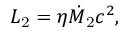Convert formula to latex. <formula><loc_0><loc_0><loc_500><loc_500>L _ { 2 } = \eta \dot { M } _ { 2 } c ^ { 2 } ,</formula> 